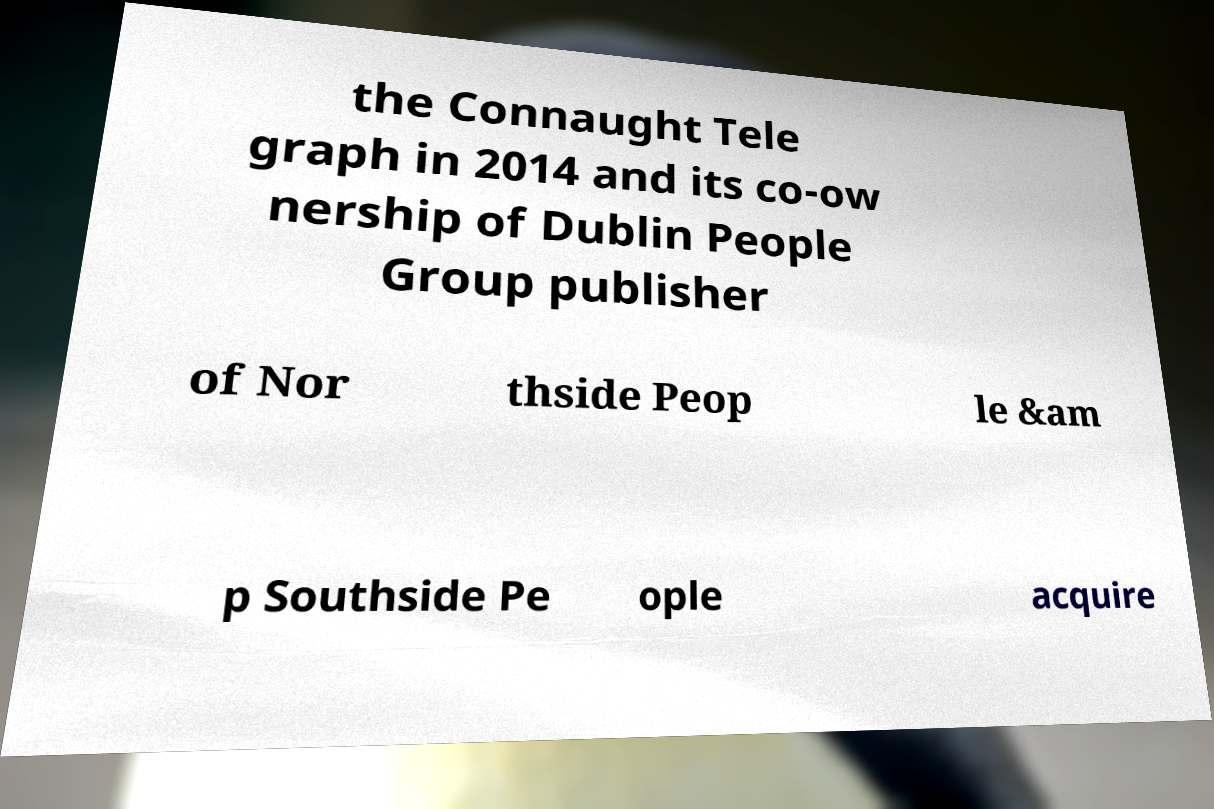Please identify and transcribe the text found in this image. the Connaught Tele graph in 2014 and its co-ow nership of Dublin People Group publisher of Nor thside Peop le &am p Southside Pe ople acquire 